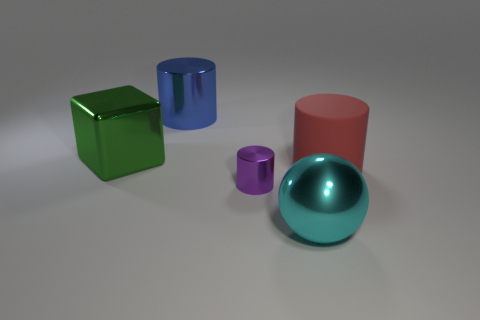There is another matte object that is the same shape as the tiny purple thing; what is its color?
Ensure brevity in your answer.  Red. Do the metal cylinder behind the big matte cylinder and the object to the right of the metallic ball have the same size?
Give a very brief answer. Yes. Is the shape of the purple object the same as the blue object?
Provide a succinct answer. Yes. What number of things are either cylinders that are left of the rubber object or cyan things?
Keep it short and to the point. 3. Are there any purple shiny things that have the same shape as the big blue object?
Give a very brief answer. Yes. Is the number of large blue metal objects right of the small purple metal cylinder the same as the number of purple shiny things?
Your response must be concise. No. How many brown rubber balls are the same size as the blue cylinder?
Ensure brevity in your answer.  0. What number of big shiny objects are behind the large red cylinder?
Keep it short and to the point. 2. What is the object in front of the purple metallic cylinder that is in front of the big green metal block made of?
Make the answer very short. Metal. Is there another large rubber thing of the same color as the rubber object?
Give a very brief answer. No. 